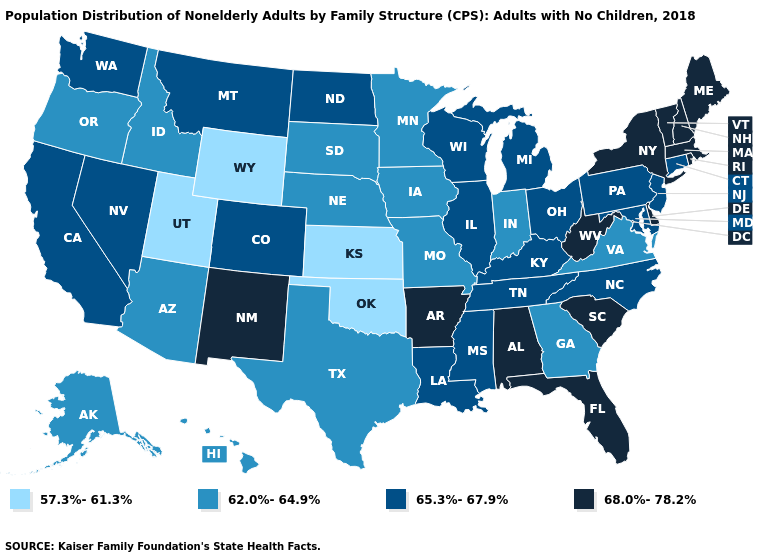What is the value of Vermont?
Keep it brief. 68.0%-78.2%. Which states have the highest value in the USA?
Short answer required. Alabama, Arkansas, Delaware, Florida, Maine, Massachusetts, New Hampshire, New Mexico, New York, Rhode Island, South Carolina, Vermont, West Virginia. Does Hawaii have the lowest value in the West?
Be succinct. No. What is the value of Rhode Island?
Be succinct. 68.0%-78.2%. Among the states that border Oregon , which have the highest value?
Answer briefly. California, Nevada, Washington. What is the value of Texas?
Be succinct. 62.0%-64.9%. What is the highest value in the USA?
Give a very brief answer. 68.0%-78.2%. What is the value of New York?
Give a very brief answer. 68.0%-78.2%. What is the lowest value in states that border Delaware?
Answer briefly. 65.3%-67.9%. Name the states that have a value in the range 57.3%-61.3%?
Keep it brief. Kansas, Oklahoma, Utah, Wyoming. What is the value of South Carolina?
Short answer required. 68.0%-78.2%. Is the legend a continuous bar?
Concise answer only. No. What is the lowest value in the USA?
Be succinct. 57.3%-61.3%. Name the states that have a value in the range 65.3%-67.9%?
Concise answer only. California, Colorado, Connecticut, Illinois, Kentucky, Louisiana, Maryland, Michigan, Mississippi, Montana, Nevada, New Jersey, North Carolina, North Dakota, Ohio, Pennsylvania, Tennessee, Washington, Wisconsin. Name the states that have a value in the range 62.0%-64.9%?
Quick response, please. Alaska, Arizona, Georgia, Hawaii, Idaho, Indiana, Iowa, Minnesota, Missouri, Nebraska, Oregon, South Dakota, Texas, Virginia. 